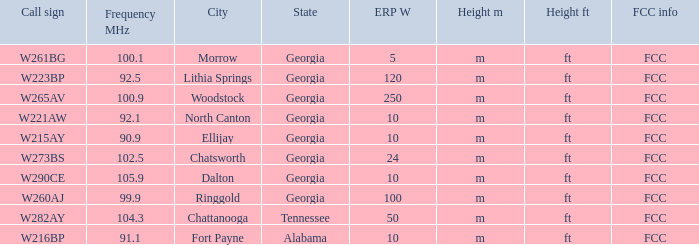What is the number of Frequency MHz in woodstock, georgia? 100.9. 